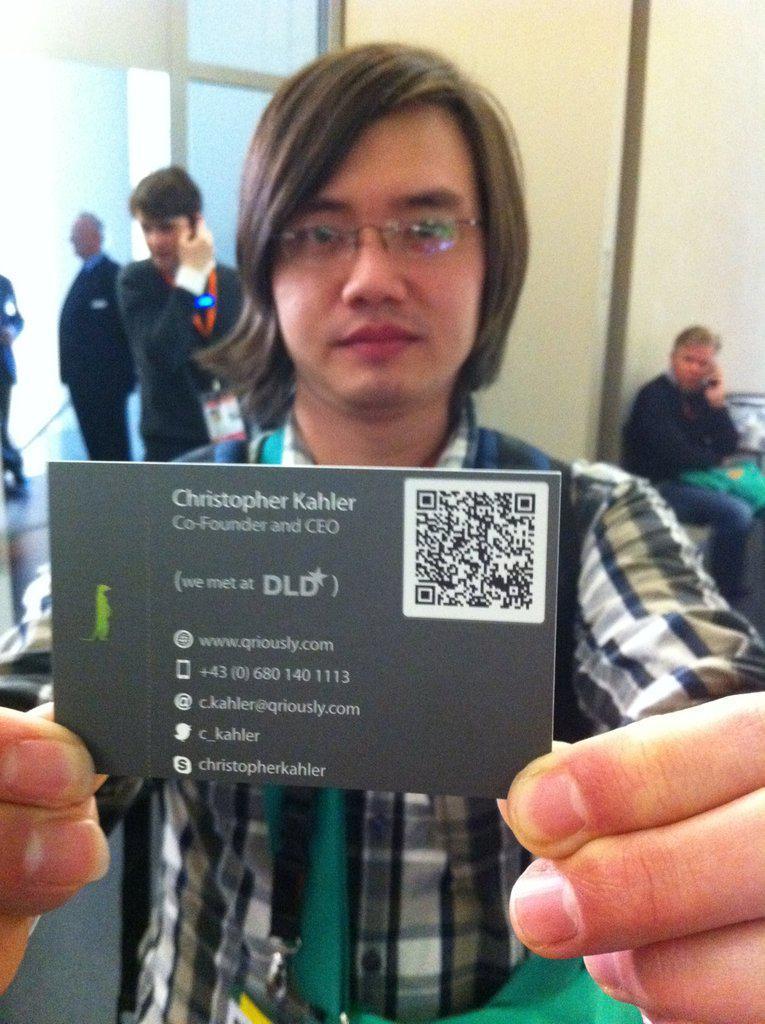How would you summarize this image in a sentence or two? In this picture we can see a man wearing checked shirt, standing in the front and holding the visiting card in the hand. Behind we can see some people are standing. In the background there is a yellow wall. 